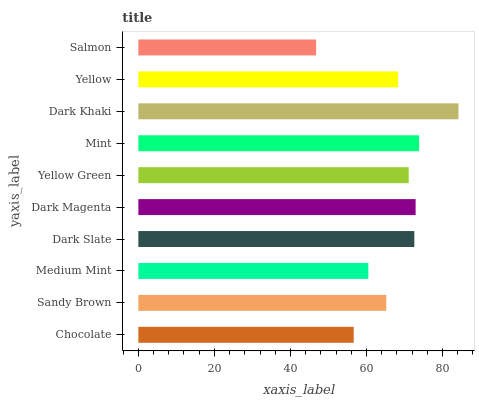Is Salmon the minimum?
Answer yes or no. Yes. Is Dark Khaki the maximum?
Answer yes or no. Yes. Is Sandy Brown the minimum?
Answer yes or no. No. Is Sandy Brown the maximum?
Answer yes or no. No. Is Sandy Brown greater than Chocolate?
Answer yes or no. Yes. Is Chocolate less than Sandy Brown?
Answer yes or no. Yes. Is Chocolate greater than Sandy Brown?
Answer yes or no. No. Is Sandy Brown less than Chocolate?
Answer yes or no. No. Is Yellow Green the high median?
Answer yes or no. Yes. Is Yellow the low median?
Answer yes or no. Yes. Is Mint the high median?
Answer yes or no. No. Is Chocolate the low median?
Answer yes or no. No. 